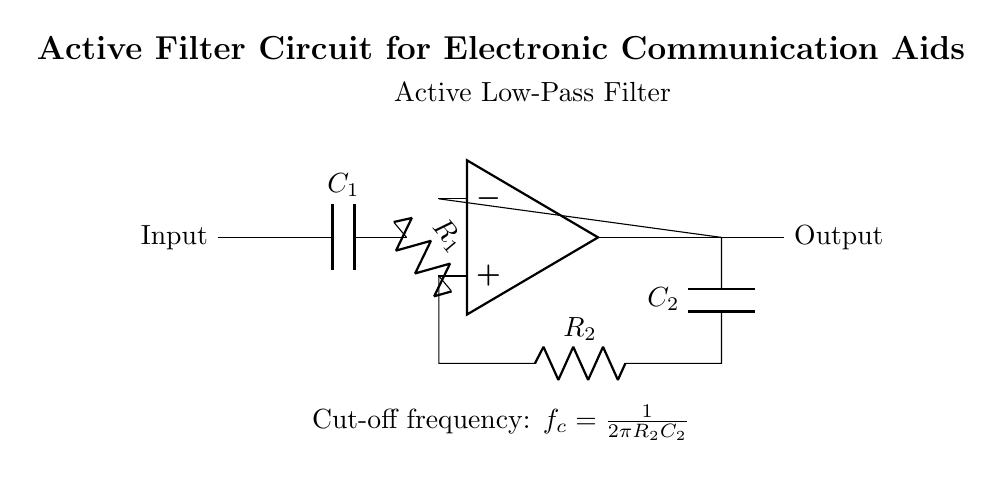What is the type of filter shown in the circuit? The circuit is labeled as an "Active Low-Pass Filter" at the top. This indicates that it allows low-frequency signals to pass through while attenuating higher-frequency signals.
Answer: Active Low-Pass Filter What is the role of C1 in this circuit? C1 is a capacitor that is connected to the input side of the circuit. Its primary role is to block direct current while allowing alternating current signals to pass, thus filtering the input signal for the desired frequencies.
Answer: Block direct current What is the feedback component in the circuit? The feedback component involves R2 and C2, which are connected between the output of the op-amp and the inverting input. This feedback is necessary to stabilize the circuit and determine its gain characteristics.
Answer: R2 and C2 What is the formula for the cut-off frequency? The cut-off frequency is indicated in the diagram as \(f_c = \frac{1}{2\pi R_2C_2}\). This formula stems from the relationship between the resistance and capacitance in the feedback path, which defines the frequency at which the output signal will start to be attenuated.
Answer: \( \frac{1}{2\pi R_2C_2} \) What does the op-amp do in this circuit? The op-amp is used as a voltage amplifier that receives the input signal, processes it, and provides a filtered output signal. It enhances the weak signal to ensure better quality for communication aids.
Answer: Voltage amplifier What does the symbol R1 represent in the circuit? R1 is a resistor that is connected between the input signal and the non-inverting input of the op-amp. It helps in setting the input impedance of the filter and plays a role in the filtering characteristics of the circuit.
Answer: Resistor connected to input 